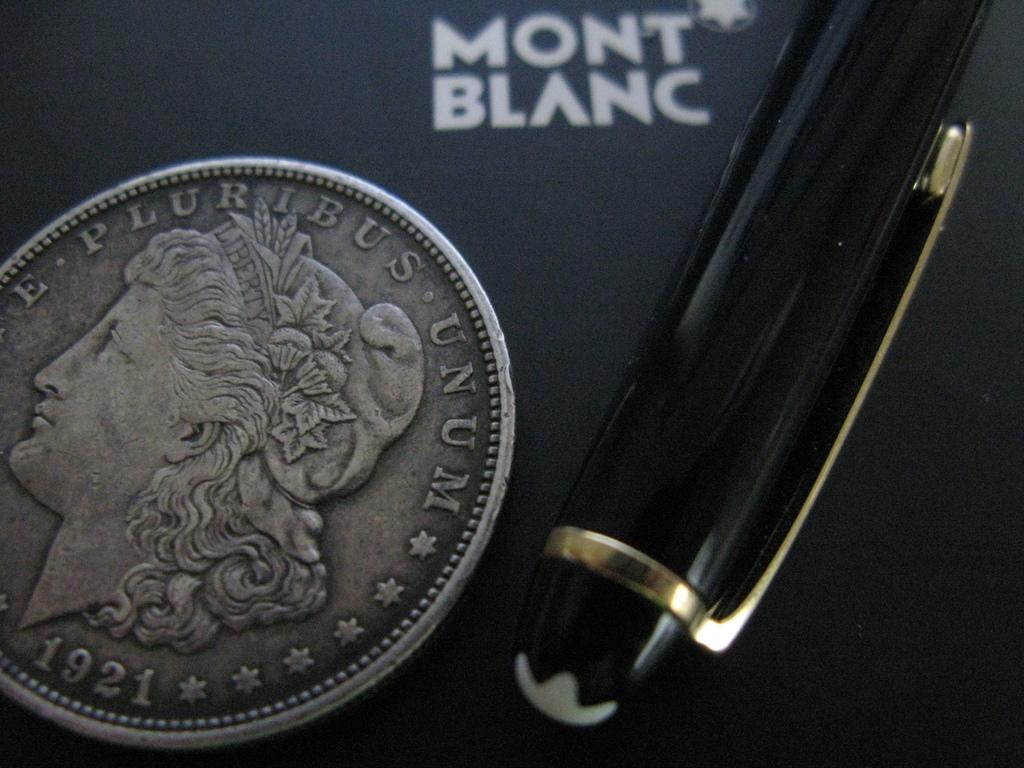What year is on this coin?
Offer a very short reply. 1921. What is on the top of the coin?
Give a very brief answer. E pluribus unum. 